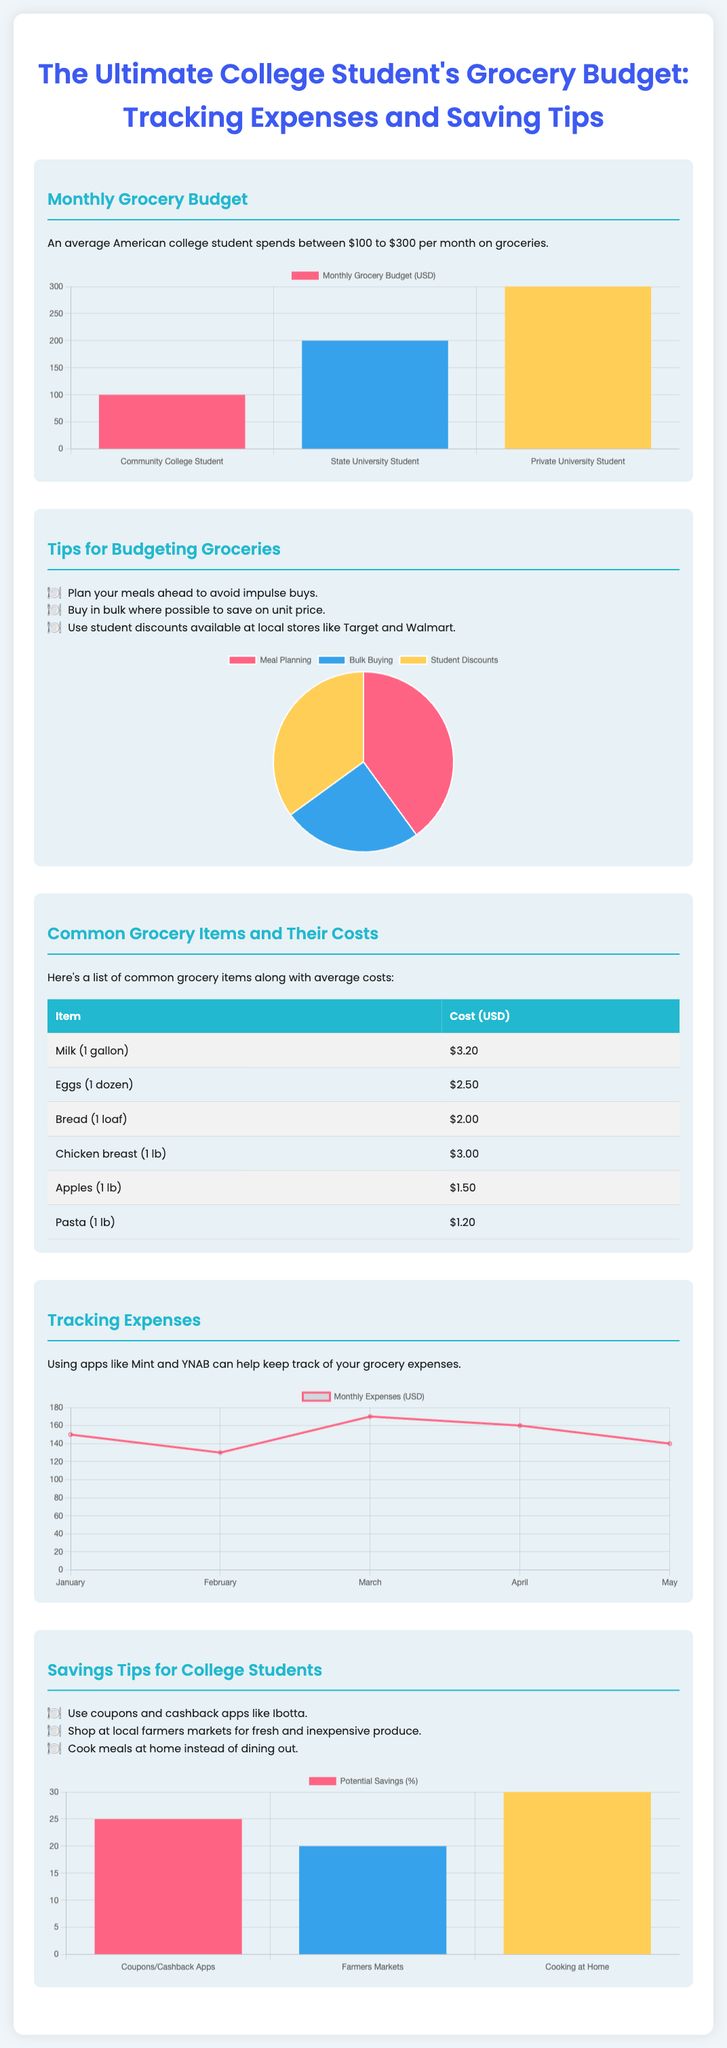how much does an average American college student spend on groceries per month? The document states that an average American college student spends between $100 to $300 per month on groceries.
Answer: $100 to $300 what are two tips for budgeting groceries mentioned in the document? The document lists several tips for budgeting groceries, including meal planning and buying in bulk.
Answer: Meal Planning, Buying in Bulk what are the average costs of eggs per dozen? There is a specific entry listing the cost of eggs in the document.
Answer: $2.50 which grocery item has the highest average cost listed? The document includes a table with costs, allowing for comparison of the grocery items.
Answer: Milk (1 gallon) what percentage of potential savings comes from cooking at home? The document provides a chart representing potential savings from various tips for college students, including cooking at home.
Answer: 30 how many months of data are used for tracking expenses in the chart? The expense tracking chart includes labels for each month, indicating the duration of tracking.
Answer: 5 what type of chart represents budgeting tips? The budgeting tips are illustrated using a specific chart type within the document.
Answer: Pie Chart 